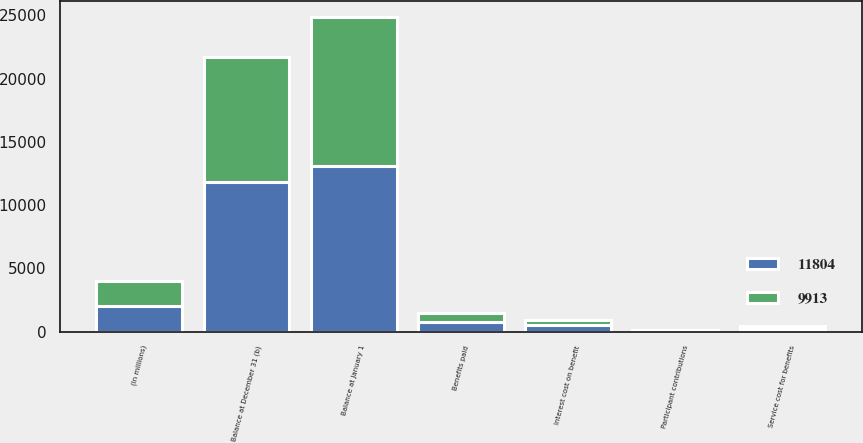Convert chart to OTSL. <chart><loc_0><loc_0><loc_500><loc_500><stacked_bar_chart><ecel><fcel>(In millions)<fcel>Balance at January 1<fcel>Service cost for benefits<fcel>Interest cost on benefit<fcel>Participant contributions<fcel>Benefits paid<fcel>Balance at December 31 (b)<nl><fcel>9913<fcel>2013<fcel>11804<fcel>229<fcel>410<fcel>52<fcel>746<fcel>9913<nl><fcel>11804<fcel>2012<fcel>13056<fcel>219<fcel>491<fcel>54<fcel>758<fcel>11804<nl></chart> 